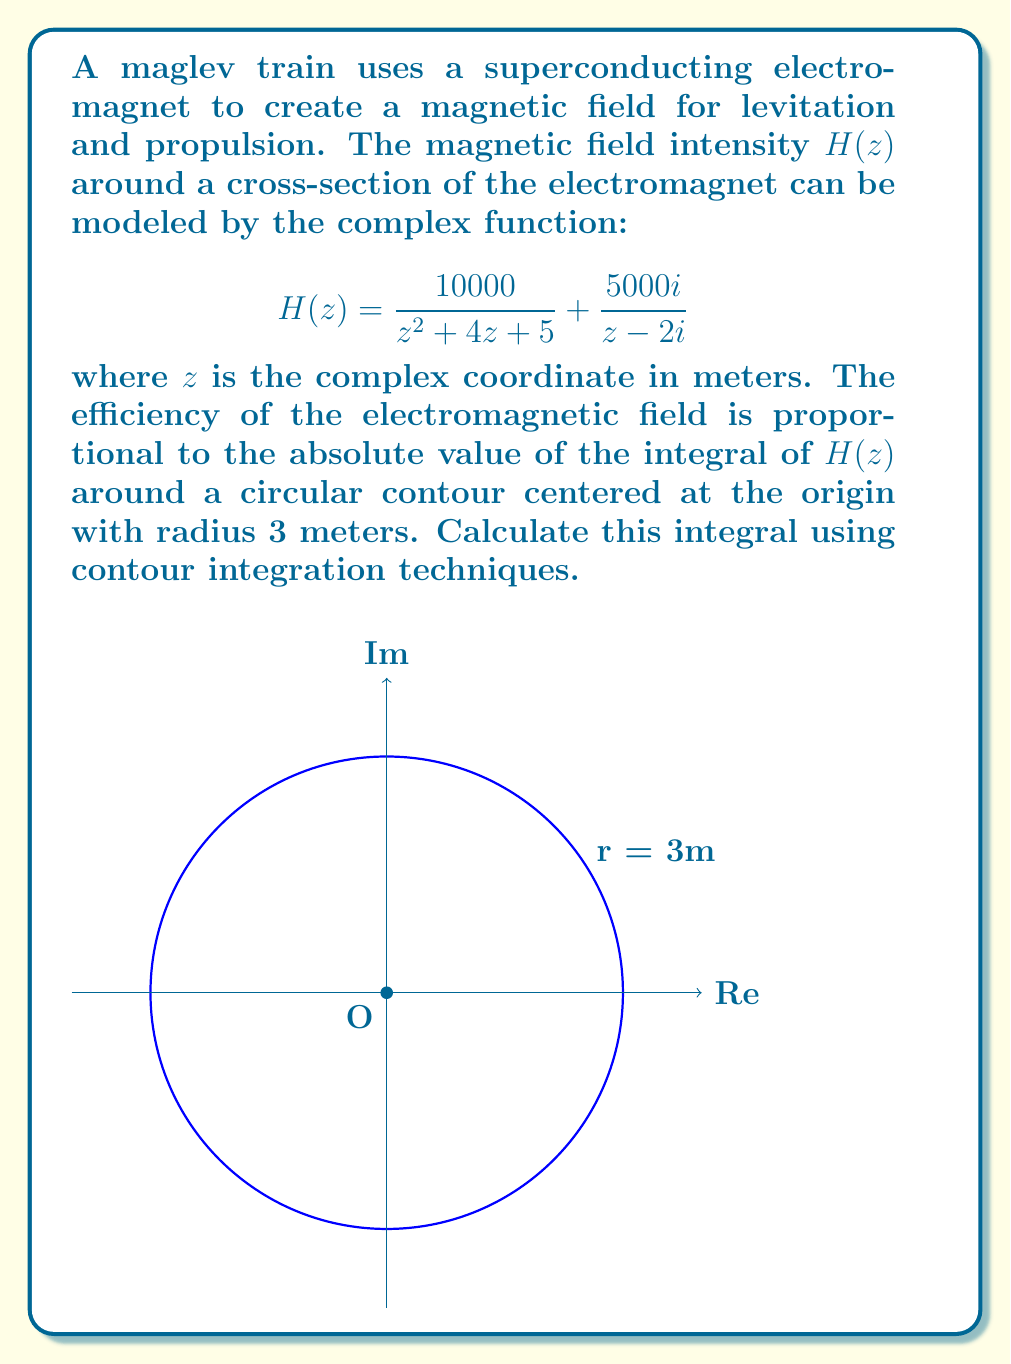Could you help me with this problem? Let's approach this problem step by step:

1) We need to evaluate the contour integral:

   $$\oint_C H(z) dz$$

   where $C$ is the circle $|z| = 3$.

2) We can use the residue theorem, which states:

   $$\oint_C f(z) dz = 2\pi i \sum_{k=1}^n \text{Res}(f, z_k)$$

   where $z_k$ are the poles of $f(z)$ inside the contour.

3) Let's find the poles of $H(z)$:
   - For the first term, $z^2 + 4z + 5 = (z+2)^2 + 1 = 0$ has no real solutions.
   - For the second term, there's a pole at $z = 2i$.

4) Only the pole at $z = 2i$ is inside our contour (since $|2i| = 2 < 3$).

5) Now, let's calculate the residue at $z = 2i$ for the second term:

   $$\text{Res}(\frac{5000i}{z - 2i}, 2i) = 5000i$$

6) For the first term, we need to use the formula for the residue at infinity:

   $$\text{Res}(f, \infty) = -\text{Res}(\frac{1}{z^2}f(\frac{1}{z}), 0)$$

   $$\frac{1}{z^2}H(\frac{1}{z}) = \frac{10000z^2}{1 + 4z + 5z^2} + \frac{5000iz^2}{1 - 2iz}$$

   The residue of this at $z = 0$ is 0, so $\text{Res}(H, \infty) = 0$.

7) Applying the residue theorem:

   $$\oint_C H(z) dz = 2\pi i (5000i) = 10000\pi$$

8) The efficiency is proportional to the absolute value of this integral:

   $$|\oint_C H(z) dz| = 10000\pi$$
Answer: $10000\pi$ 